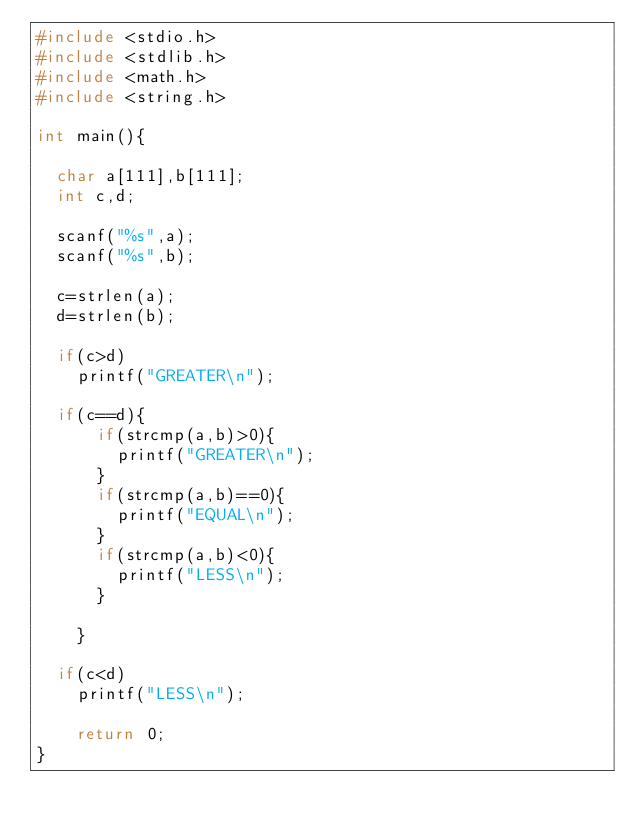Convert code to text. <code><loc_0><loc_0><loc_500><loc_500><_C_>#include <stdio.h>
#include <stdlib.h>
#include <math.h>
#include <string.h>

int main(){

  char a[111],b[111];
  int c,d;

  scanf("%s",a);
  scanf("%s",b);

  c=strlen(a);
  d=strlen(b);

  if(c>d)
    printf("GREATER\n");

  if(c==d){
      if(strcmp(a,b)>0){
        printf("GREATER\n");
      }
      if(strcmp(a,b)==0){
        printf("EQUAL\n");
      }
      if(strcmp(a,b)<0){
        printf("LESS\n");
      }

    }

  if(c<d)
    printf("LESS\n");

    return 0;
}
</code> 